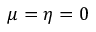<formula> <loc_0><loc_0><loc_500><loc_500>\mu = \eta = 0</formula> 